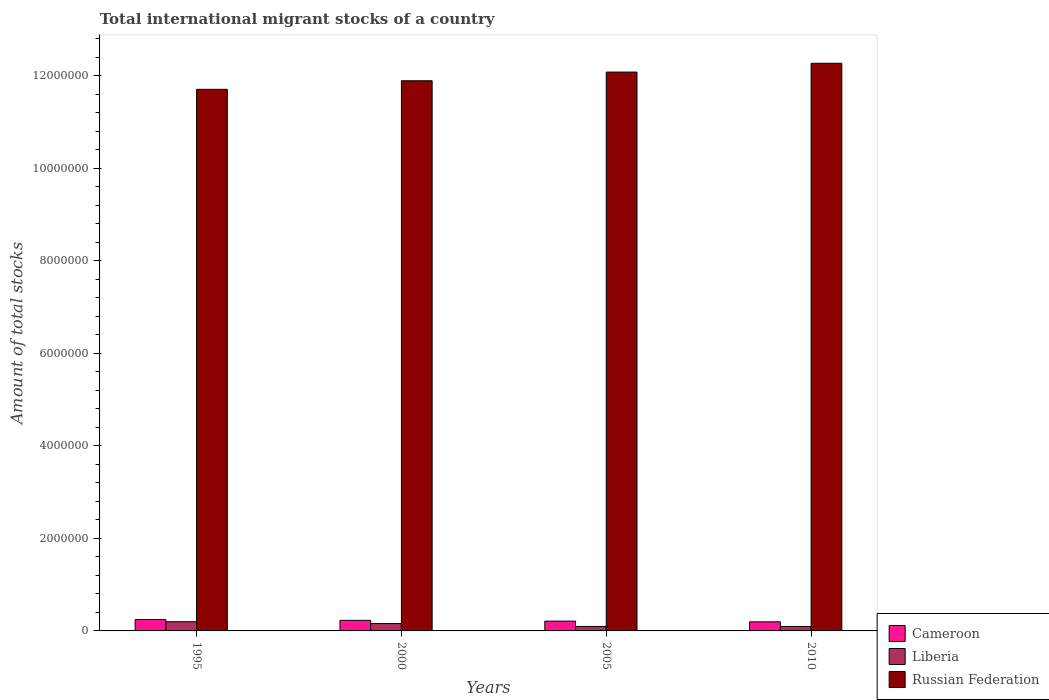How many bars are there on the 2nd tick from the left?
Provide a short and direct response. 3. How many bars are there on the 4th tick from the right?
Your response must be concise. 3. What is the label of the 4th group of bars from the left?
Provide a succinct answer. 2010. What is the amount of total stocks in in Cameroon in 2010?
Your response must be concise. 1.97e+05. Across all years, what is the maximum amount of total stocks in in Russian Federation?
Provide a short and direct response. 1.23e+07. Across all years, what is the minimum amount of total stocks in in Russian Federation?
Ensure brevity in your answer.  1.17e+07. In which year was the amount of total stocks in in Cameroon maximum?
Give a very brief answer. 1995. In which year was the amount of total stocks in in Cameroon minimum?
Your response must be concise. 2010. What is the total amount of total stocks in in Russian Federation in the graph?
Ensure brevity in your answer.  4.79e+07. What is the difference between the amount of total stocks in in Russian Federation in 2000 and that in 2010?
Offer a very short reply. -3.79e+05. What is the difference between the amount of total stocks in in Cameroon in 2000 and the amount of total stocks in in Russian Federation in 2005?
Ensure brevity in your answer.  -1.19e+07. What is the average amount of total stocks in in Cameroon per year?
Make the answer very short. 2.21e+05. In the year 2005, what is the difference between the amount of total stocks in in Cameroon and amount of total stocks in in Russian Federation?
Your response must be concise. -1.19e+07. In how many years, is the amount of total stocks in in Cameroon greater than 12400000?
Give a very brief answer. 0. What is the ratio of the amount of total stocks in in Russian Federation in 2005 to that in 2010?
Your answer should be compact. 0.98. Is the amount of total stocks in in Russian Federation in 1995 less than that in 2010?
Offer a terse response. Yes. Is the difference between the amount of total stocks in in Cameroon in 1995 and 2010 greater than the difference between the amount of total stocks in in Russian Federation in 1995 and 2010?
Provide a short and direct response. Yes. What is the difference between the highest and the second highest amount of total stocks in in Russian Federation?
Provide a succinct answer. 1.91e+05. What is the difference between the highest and the lowest amount of total stocks in in Russian Federation?
Ensure brevity in your answer.  5.63e+05. Is the sum of the amount of total stocks in in Russian Federation in 2000 and 2005 greater than the maximum amount of total stocks in in Liberia across all years?
Provide a short and direct response. Yes. What does the 1st bar from the left in 2000 represents?
Give a very brief answer. Cameroon. What does the 1st bar from the right in 2000 represents?
Offer a terse response. Russian Federation. How many bars are there?
Your response must be concise. 12. Are all the bars in the graph horizontal?
Offer a very short reply. No. What is the difference between two consecutive major ticks on the Y-axis?
Make the answer very short. 2.00e+06. Does the graph contain grids?
Make the answer very short. No. How are the legend labels stacked?
Provide a succinct answer. Vertical. What is the title of the graph?
Keep it short and to the point. Total international migrant stocks of a country. What is the label or title of the X-axis?
Offer a terse response. Years. What is the label or title of the Y-axis?
Provide a succinct answer. Amount of total stocks. What is the Amount of total stocks in Cameroon in 1995?
Your answer should be compact. 2.46e+05. What is the Amount of total stocks of Liberia in 1995?
Keep it short and to the point. 1.99e+05. What is the Amount of total stocks in Russian Federation in 1995?
Ensure brevity in your answer.  1.17e+07. What is the Amount of total stocks of Cameroon in 2000?
Your answer should be compact. 2.28e+05. What is the Amount of total stocks in Liberia in 2000?
Offer a terse response. 1.60e+05. What is the Amount of total stocks of Russian Federation in 2000?
Offer a very short reply. 1.19e+07. What is the Amount of total stocks of Cameroon in 2005?
Provide a short and direct response. 2.12e+05. What is the Amount of total stocks in Liberia in 2005?
Your response must be concise. 9.68e+04. What is the Amount of total stocks of Russian Federation in 2005?
Your answer should be compact. 1.21e+07. What is the Amount of total stocks of Cameroon in 2010?
Provide a short and direct response. 1.97e+05. What is the Amount of total stocks in Liberia in 2010?
Your answer should be compact. 9.63e+04. What is the Amount of total stocks in Russian Federation in 2010?
Offer a terse response. 1.23e+07. Across all years, what is the maximum Amount of total stocks in Cameroon?
Ensure brevity in your answer.  2.46e+05. Across all years, what is the maximum Amount of total stocks of Liberia?
Offer a terse response. 1.99e+05. Across all years, what is the maximum Amount of total stocks in Russian Federation?
Provide a succinct answer. 1.23e+07. Across all years, what is the minimum Amount of total stocks in Cameroon?
Provide a short and direct response. 1.97e+05. Across all years, what is the minimum Amount of total stocks in Liberia?
Give a very brief answer. 9.63e+04. Across all years, what is the minimum Amount of total stocks of Russian Federation?
Provide a short and direct response. 1.17e+07. What is the total Amount of total stocks of Cameroon in the graph?
Ensure brevity in your answer.  8.83e+05. What is the total Amount of total stocks of Liberia in the graph?
Give a very brief answer. 5.52e+05. What is the total Amount of total stocks in Russian Federation in the graph?
Keep it short and to the point. 4.79e+07. What is the difference between the Amount of total stocks of Cameroon in 1995 and that in 2000?
Your response must be concise. 1.78e+04. What is the difference between the Amount of total stocks in Liberia in 1995 and that in 2000?
Give a very brief answer. 3.92e+04. What is the difference between the Amount of total stocks in Russian Federation in 1995 and that in 2000?
Your answer should be very brief. -1.85e+05. What is the difference between the Amount of total stocks in Cameroon in 1995 and that in 2005?
Make the answer very short. 3.43e+04. What is the difference between the Amount of total stocks of Liberia in 1995 and that in 2005?
Your answer should be compact. 1.02e+05. What is the difference between the Amount of total stocks of Russian Federation in 1995 and that in 2005?
Make the answer very short. -3.73e+05. What is the difference between the Amount of total stocks in Cameroon in 1995 and that in 2010?
Keep it short and to the point. 4.96e+04. What is the difference between the Amount of total stocks in Liberia in 1995 and that in 2010?
Make the answer very short. 1.03e+05. What is the difference between the Amount of total stocks in Russian Federation in 1995 and that in 2010?
Keep it short and to the point. -5.63e+05. What is the difference between the Amount of total stocks of Cameroon in 2000 and that in 2005?
Your answer should be compact. 1.65e+04. What is the difference between the Amount of total stocks of Liberia in 2000 and that in 2005?
Offer a very short reply. 6.28e+04. What is the difference between the Amount of total stocks in Russian Federation in 2000 and that in 2005?
Your response must be concise. -1.88e+05. What is the difference between the Amount of total stocks of Cameroon in 2000 and that in 2010?
Offer a very short reply. 3.18e+04. What is the difference between the Amount of total stocks in Liberia in 2000 and that in 2010?
Your response must be concise. 6.33e+04. What is the difference between the Amount of total stocks of Russian Federation in 2000 and that in 2010?
Your answer should be compact. -3.79e+05. What is the difference between the Amount of total stocks in Cameroon in 2005 and that in 2010?
Offer a terse response. 1.53e+04. What is the difference between the Amount of total stocks in Liberia in 2005 and that in 2010?
Provide a short and direct response. 483. What is the difference between the Amount of total stocks in Russian Federation in 2005 and that in 2010?
Offer a terse response. -1.91e+05. What is the difference between the Amount of total stocks in Cameroon in 1995 and the Amount of total stocks in Liberia in 2000?
Ensure brevity in your answer.  8.66e+04. What is the difference between the Amount of total stocks of Cameroon in 1995 and the Amount of total stocks of Russian Federation in 2000?
Your answer should be very brief. -1.16e+07. What is the difference between the Amount of total stocks of Liberia in 1995 and the Amount of total stocks of Russian Federation in 2000?
Keep it short and to the point. -1.17e+07. What is the difference between the Amount of total stocks in Cameroon in 1995 and the Amount of total stocks in Liberia in 2005?
Ensure brevity in your answer.  1.49e+05. What is the difference between the Amount of total stocks in Cameroon in 1995 and the Amount of total stocks in Russian Federation in 2005?
Provide a succinct answer. -1.18e+07. What is the difference between the Amount of total stocks in Liberia in 1995 and the Amount of total stocks in Russian Federation in 2005?
Offer a very short reply. -1.19e+07. What is the difference between the Amount of total stocks in Cameroon in 1995 and the Amount of total stocks in Liberia in 2010?
Make the answer very short. 1.50e+05. What is the difference between the Amount of total stocks in Cameroon in 1995 and the Amount of total stocks in Russian Federation in 2010?
Provide a succinct answer. -1.20e+07. What is the difference between the Amount of total stocks in Liberia in 1995 and the Amount of total stocks in Russian Federation in 2010?
Your response must be concise. -1.21e+07. What is the difference between the Amount of total stocks of Cameroon in 2000 and the Amount of total stocks of Liberia in 2005?
Your answer should be very brief. 1.32e+05. What is the difference between the Amount of total stocks in Cameroon in 2000 and the Amount of total stocks in Russian Federation in 2005?
Your answer should be compact. -1.19e+07. What is the difference between the Amount of total stocks in Liberia in 2000 and the Amount of total stocks in Russian Federation in 2005?
Give a very brief answer. -1.19e+07. What is the difference between the Amount of total stocks in Cameroon in 2000 and the Amount of total stocks in Liberia in 2010?
Make the answer very short. 1.32e+05. What is the difference between the Amount of total stocks of Cameroon in 2000 and the Amount of total stocks of Russian Federation in 2010?
Your response must be concise. -1.20e+07. What is the difference between the Amount of total stocks of Liberia in 2000 and the Amount of total stocks of Russian Federation in 2010?
Keep it short and to the point. -1.21e+07. What is the difference between the Amount of total stocks in Cameroon in 2005 and the Amount of total stocks in Liberia in 2010?
Give a very brief answer. 1.16e+05. What is the difference between the Amount of total stocks in Cameroon in 2005 and the Amount of total stocks in Russian Federation in 2010?
Your answer should be compact. -1.21e+07. What is the difference between the Amount of total stocks in Liberia in 2005 and the Amount of total stocks in Russian Federation in 2010?
Ensure brevity in your answer.  -1.22e+07. What is the average Amount of total stocks of Cameroon per year?
Make the answer very short. 2.21e+05. What is the average Amount of total stocks of Liberia per year?
Provide a succinct answer. 1.38e+05. What is the average Amount of total stocks in Russian Federation per year?
Provide a succinct answer. 1.20e+07. In the year 1995, what is the difference between the Amount of total stocks of Cameroon and Amount of total stocks of Liberia?
Offer a terse response. 4.73e+04. In the year 1995, what is the difference between the Amount of total stocks of Cameroon and Amount of total stocks of Russian Federation?
Provide a short and direct response. -1.15e+07. In the year 1995, what is the difference between the Amount of total stocks of Liberia and Amount of total stocks of Russian Federation?
Your response must be concise. -1.15e+07. In the year 2000, what is the difference between the Amount of total stocks of Cameroon and Amount of total stocks of Liberia?
Keep it short and to the point. 6.88e+04. In the year 2000, what is the difference between the Amount of total stocks in Cameroon and Amount of total stocks in Russian Federation?
Provide a succinct answer. -1.17e+07. In the year 2000, what is the difference between the Amount of total stocks in Liberia and Amount of total stocks in Russian Federation?
Offer a terse response. -1.17e+07. In the year 2005, what is the difference between the Amount of total stocks in Cameroon and Amount of total stocks in Liberia?
Offer a terse response. 1.15e+05. In the year 2005, what is the difference between the Amount of total stocks in Cameroon and Amount of total stocks in Russian Federation?
Keep it short and to the point. -1.19e+07. In the year 2005, what is the difference between the Amount of total stocks of Liberia and Amount of total stocks of Russian Federation?
Provide a short and direct response. -1.20e+07. In the year 2010, what is the difference between the Amount of total stocks in Cameroon and Amount of total stocks in Liberia?
Your response must be concise. 1.00e+05. In the year 2010, what is the difference between the Amount of total stocks of Cameroon and Amount of total stocks of Russian Federation?
Ensure brevity in your answer.  -1.21e+07. In the year 2010, what is the difference between the Amount of total stocks of Liberia and Amount of total stocks of Russian Federation?
Your answer should be compact. -1.22e+07. What is the ratio of the Amount of total stocks in Cameroon in 1995 to that in 2000?
Offer a very short reply. 1.08. What is the ratio of the Amount of total stocks of Liberia in 1995 to that in 2000?
Make the answer very short. 1.25. What is the ratio of the Amount of total stocks in Russian Federation in 1995 to that in 2000?
Provide a succinct answer. 0.98. What is the ratio of the Amount of total stocks in Cameroon in 1995 to that in 2005?
Keep it short and to the point. 1.16. What is the ratio of the Amount of total stocks of Liberia in 1995 to that in 2005?
Keep it short and to the point. 2.05. What is the ratio of the Amount of total stocks of Russian Federation in 1995 to that in 2005?
Ensure brevity in your answer.  0.97. What is the ratio of the Amount of total stocks in Cameroon in 1995 to that in 2010?
Make the answer very short. 1.25. What is the ratio of the Amount of total stocks in Liberia in 1995 to that in 2010?
Provide a succinct answer. 2.06. What is the ratio of the Amount of total stocks in Russian Federation in 1995 to that in 2010?
Ensure brevity in your answer.  0.95. What is the ratio of the Amount of total stocks in Cameroon in 2000 to that in 2005?
Make the answer very short. 1.08. What is the ratio of the Amount of total stocks in Liberia in 2000 to that in 2005?
Give a very brief answer. 1.65. What is the ratio of the Amount of total stocks of Russian Federation in 2000 to that in 2005?
Give a very brief answer. 0.98. What is the ratio of the Amount of total stocks in Cameroon in 2000 to that in 2010?
Your answer should be very brief. 1.16. What is the ratio of the Amount of total stocks in Liberia in 2000 to that in 2010?
Make the answer very short. 1.66. What is the ratio of the Amount of total stocks of Russian Federation in 2000 to that in 2010?
Your answer should be compact. 0.97. What is the ratio of the Amount of total stocks in Cameroon in 2005 to that in 2010?
Provide a succinct answer. 1.08. What is the ratio of the Amount of total stocks in Russian Federation in 2005 to that in 2010?
Provide a short and direct response. 0.98. What is the difference between the highest and the second highest Amount of total stocks of Cameroon?
Your answer should be compact. 1.78e+04. What is the difference between the highest and the second highest Amount of total stocks of Liberia?
Provide a succinct answer. 3.92e+04. What is the difference between the highest and the second highest Amount of total stocks of Russian Federation?
Give a very brief answer. 1.91e+05. What is the difference between the highest and the lowest Amount of total stocks of Cameroon?
Your response must be concise. 4.96e+04. What is the difference between the highest and the lowest Amount of total stocks of Liberia?
Provide a succinct answer. 1.03e+05. What is the difference between the highest and the lowest Amount of total stocks in Russian Federation?
Your answer should be very brief. 5.63e+05. 